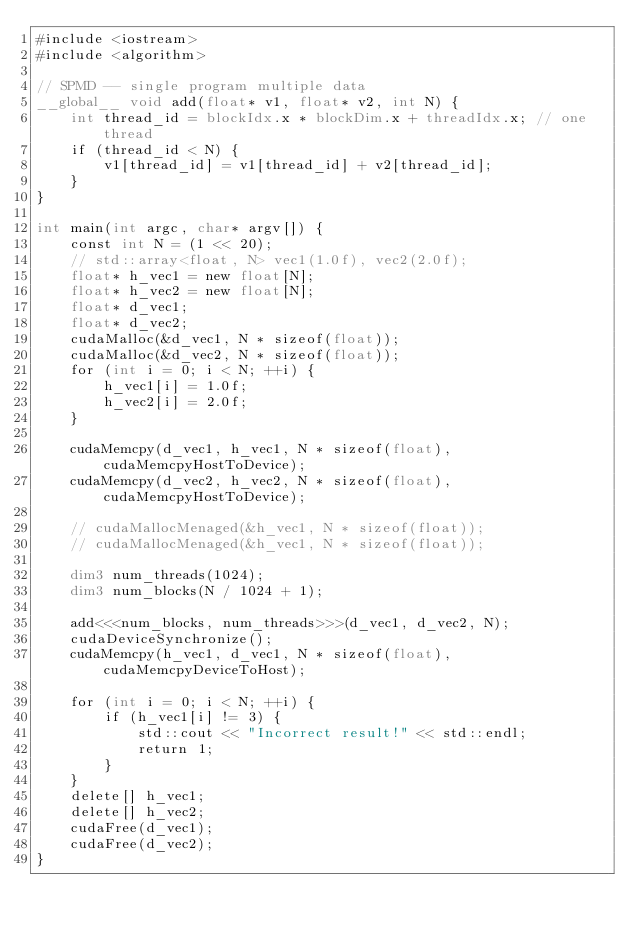Convert code to text. <code><loc_0><loc_0><loc_500><loc_500><_Cuda_>#include <iostream>
#include <algorithm>

// SPMD -- single program multiple data
__global__ void add(float* v1, float* v2, int N) {
    int thread_id = blockIdx.x * blockDim.x + threadIdx.x; // one thread 
    if (thread_id < N) {
        v1[thread_id] = v1[thread_id] + v2[thread_id];
    }
}

int main(int argc, char* argv[]) {
    const int N = (1 << 20);
    // std::array<float, N> vec1(1.0f), vec2(2.0f);
    float* h_vec1 = new float[N];
    float* h_vec2 = new float[N];
    float* d_vec1;
    float* d_vec2;
    cudaMalloc(&d_vec1, N * sizeof(float));
    cudaMalloc(&d_vec2, N * sizeof(float));
    for (int i = 0; i < N; ++i) {
        h_vec1[i] = 1.0f;
        h_vec2[i] = 2.0f;
    }

    cudaMemcpy(d_vec1, h_vec1, N * sizeof(float), cudaMemcpyHostToDevice);
    cudaMemcpy(d_vec2, h_vec2, N * sizeof(float), cudaMemcpyHostToDevice);

    // cudaMallocMenaged(&h_vec1, N * sizeof(float));
    // cudaMallocMenaged(&h_vec1, N * sizeof(float));

    dim3 num_threads(1024);
    dim3 num_blocks(N / 1024 + 1);

    add<<<num_blocks, num_threads>>>(d_vec1, d_vec2, N);
    cudaDeviceSynchronize();
    cudaMemcpy(h_vec1, d_vec1, N * sizeof(float), cudaMemcpyDeviceToHost);

    for (int i = 0; i < N; ++i) {
        if (h_vec1[i] != 3) {
            std::cout << "Incorrect result!" << std::endl;
            return 1;
        }
    }
    delete[] h_vec1;
    delete[] h_vec2;
    cudaFree(d_vec1);
    cudaFree(d_vec2);
}
</code> 